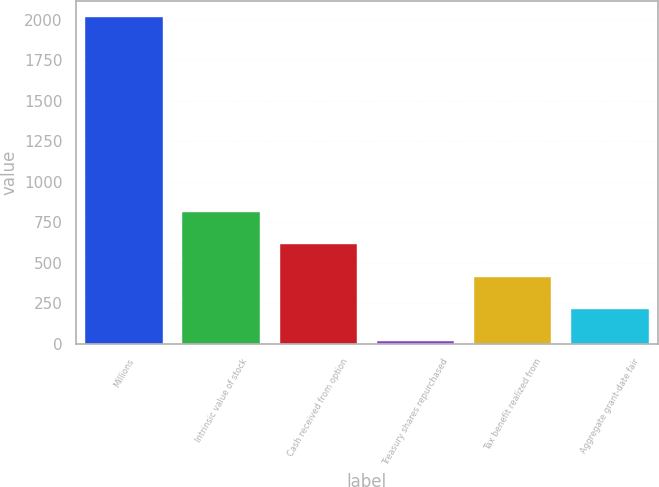Convert chart. <chart><loc_0><loc_0><loc_500><loc_500><bar_chart><fcel>Millions<fcel>Intrinsic value of stock<fcel>Cash received from option<fcel>Treasury shares repurchased<fcel>Tax benefit realized from<fcel>Aggregate grant-date fair<nl><fcel>2016<fcel>815.4<fcel>615.3<fcel>15<fcel>415.2<fcel>215.1<nl></chart> 